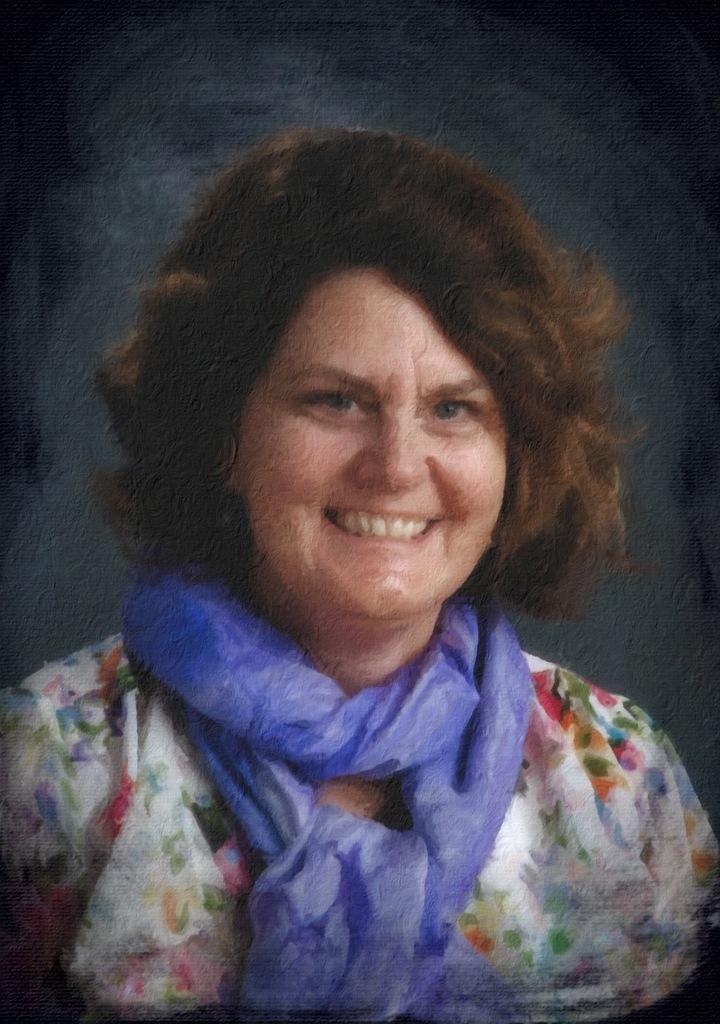Please provide a concise description of this image. This is a painting of a woman. 